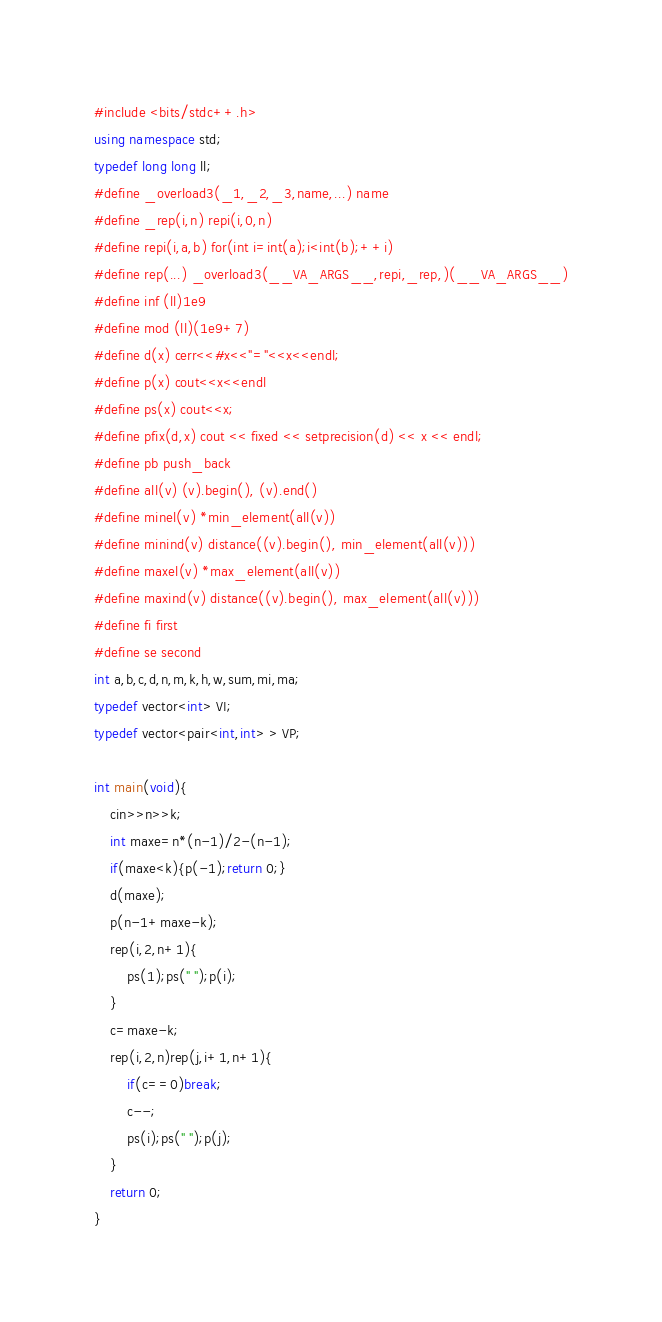Convert code to text. <code><loc_0><loc_0><loc_500><loc_500><_C++_>#include <bits/stdc++.h>
using namespace std;
typedef long long ll;
#define _overload3(_1,_2,_3,name,...) name
#define _rep(i,n) repi(i,0,n)
#define repi(i,a,b) for(int i=int(a);i<int(b);++i)
#define rep(...) _overload3(__VA_ARGS__,repi,_rep,)(__VA_ARGS__)
#define inf (ll)1e9
#define mod (ll)(1e9+7)
#define d(x) cerr<<#x<<"="<<x<<endl;
#define p(x) cout<<x<<endl
#define ps(x) cout<<x;
#define pfix(d,x) cout << fixed << setprecision(d) << x << endl;
#define pb push_back
#define all(v) (v).begin(), (v).end()
#define minel(v) *min_element(all(v))
#define minind(v) distance((v).begin(), min_element(all(v)))
#define maxel(v) *max_element(all(v))
#define maxind(v) distance((v).begin(), max_element(all(v)))
#define fi first
#define se second
int a,b,c,d,n,m,k,h,w,sum,mi,ma;
typedef vector<int> VI;
typedef vector<pair<int,int> > VP;

int main(void){
    cin>>n>>k;
    int maxe=n*(n-1)/2-(n-1);
    if(maxe<k){p(-1);return 0;}
    d(maxe);
    p(n-1+maxe-k);
    rep(i,2,n+1){
        ps(1);ps(" ");p(i);
    }
    c=maxe-k;
    rep(i,2,n)rep(j,i+1,n+1){
        if(c==0)break;
        c--;
        ps(i);ps(" ");p(j);
    }
    return 0;
}
</code> 